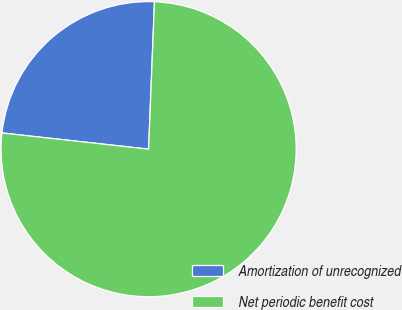<chart> <loc_0><loc_0><loc_500><loc_500><pie_chart><fcel>Amortization of unrecognized<fcel>Net periodic benefit cost<nl><fcel>23.88%<fcel>76.12%<nl></chart> 